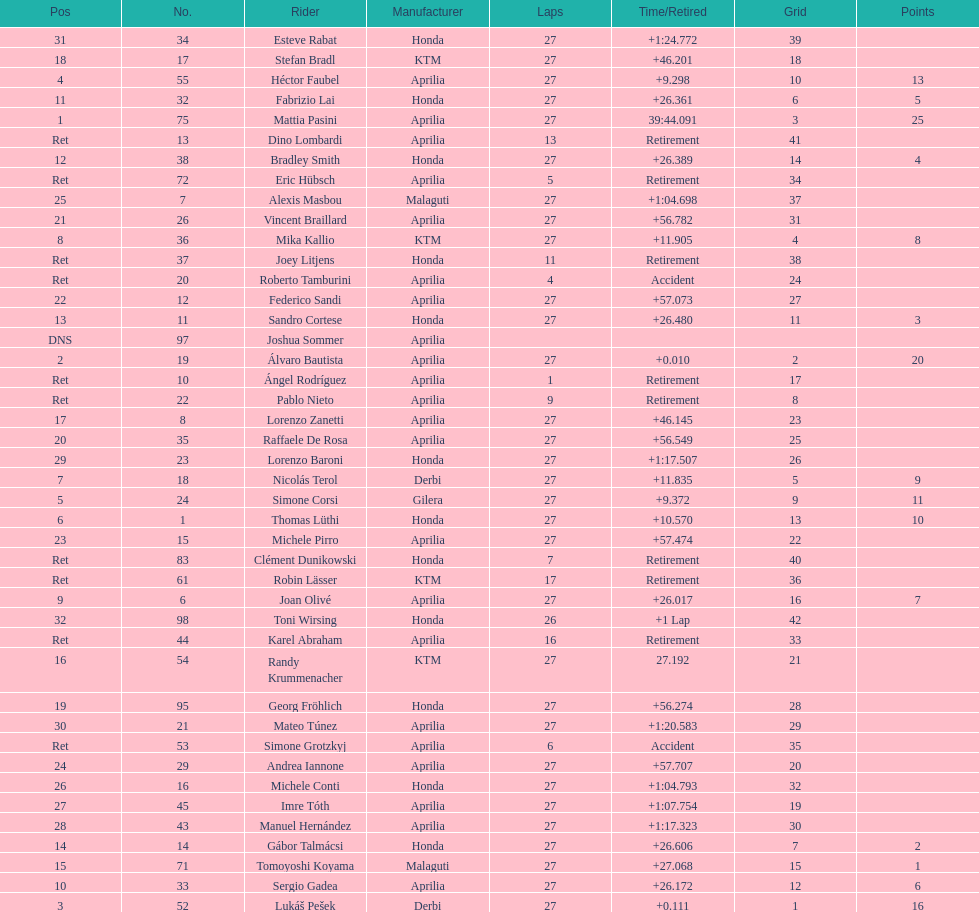How many racers did not use an aprilia or a honda? 9. 